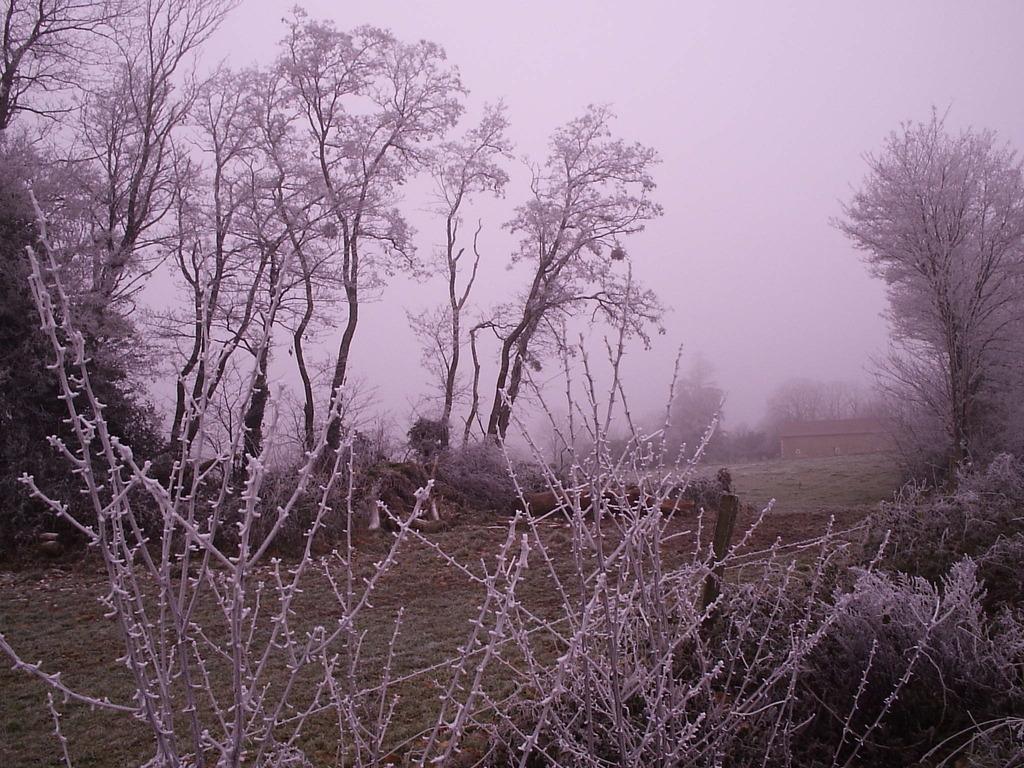How would you summarize this image in a sentence or two? In this picture we can see tree, grass, houses and we can see snow. 